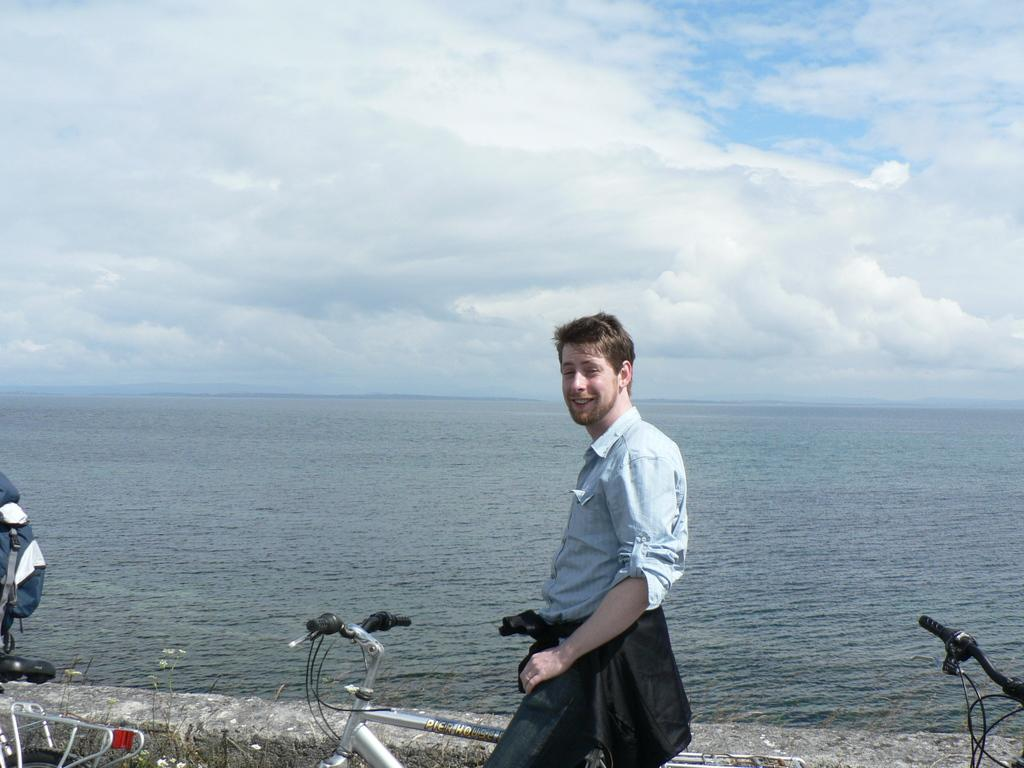What is the man in the image doing? The man is on a cycle in the image. How does the man appear in the image? The man has a smile on his face in the image. What can be seen in the background of the image? There is water and the sky visible in the background of the image. How many cycles are present in the image? There are other cycles in the image besides the one the man is on. What item is present in the image that might be used for carrying belongings? There is a bag in the image. Where is the lamp located in the image? There is no lamp present in the image. What type of nest can be seen in the image? There is no nest present in the image. 